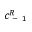<formula> <loc_0><loc_0><loc_500><loc_500>c _ { - 1 } ^ { R }</formula> 